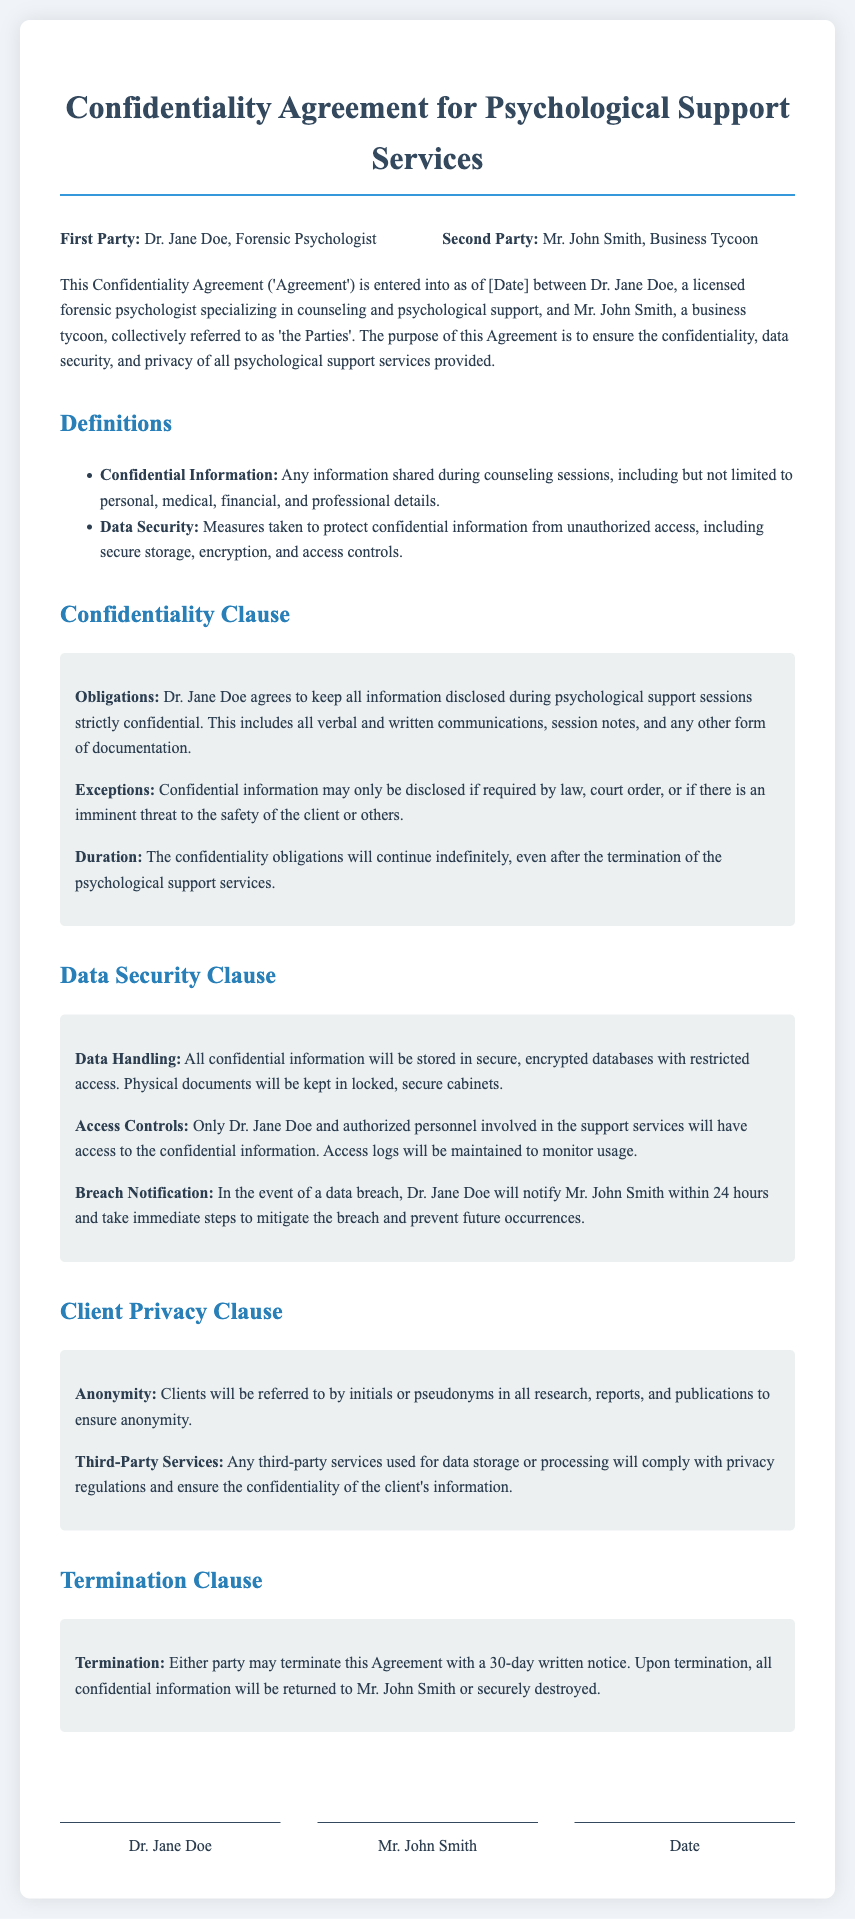what is the name of the first party? The first party is Dr. Jane Doe, who is a forensic psychologist.
Answer: Dr. Jane Doe who is the second party? The second party in the agreement is Mr. John Smith.
Answer: Mr. John Smith what is the purpose of the agreement? The purpose of the agreement is to ensure the confidentiality, data security, and privacy of all psychological support services provided.
Answer: To ensure confidentiality, data security, and privacy how long do confidentiality obligations continue after termination? The confidentiality obligations will continue indefinitely, even after the termination of the psychological support services.
Answer: Indefinitely what must happen in the event of a data breach? Dr. Jane Doe will notify Mr. John Smith within 24 hours and take immediate steps to mitigate the breach.
Answer: Notify within 24 hours how can either party terminate the agreement? Either party can terminate with a 30-day written notice.
Answer: 30-day written notice what term is used to describe measures taken to protect confidential information? The term used is Data Security.
Answer: Data Security how will clients be referred to in reports to ensure anonymity? Clients will be referred to by initials or pseudonyms.
Answer: Initials or pseudonyms what happens to confidential information upon termination? All confidential information will be returned to Mr. John Smith or securely destroyed.
Answer: Returned or securely destroyed 